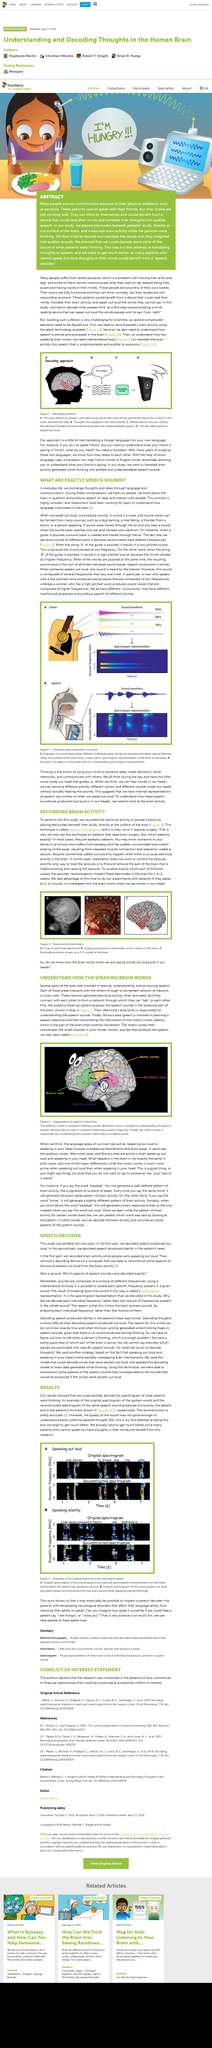Highlight a few significant elements in this photo. The process of understanding how language is encoded in the brain is highly complex and has been the subject of research for many years by scientists and researchers. During conversations, individuals engage in the act of listening to others, contemplating the topic at hand, and producing verbal responses to interact and communicate with one another. The article discusses the use of an example to illustrate the concept of the original spoken words represented by a spectrogram. The decoding device is built on a computer. Decodable sentence: "Speech in the head can be decoded by recording brain activity and using it to decode the activity when speech is produced silently in the head. 